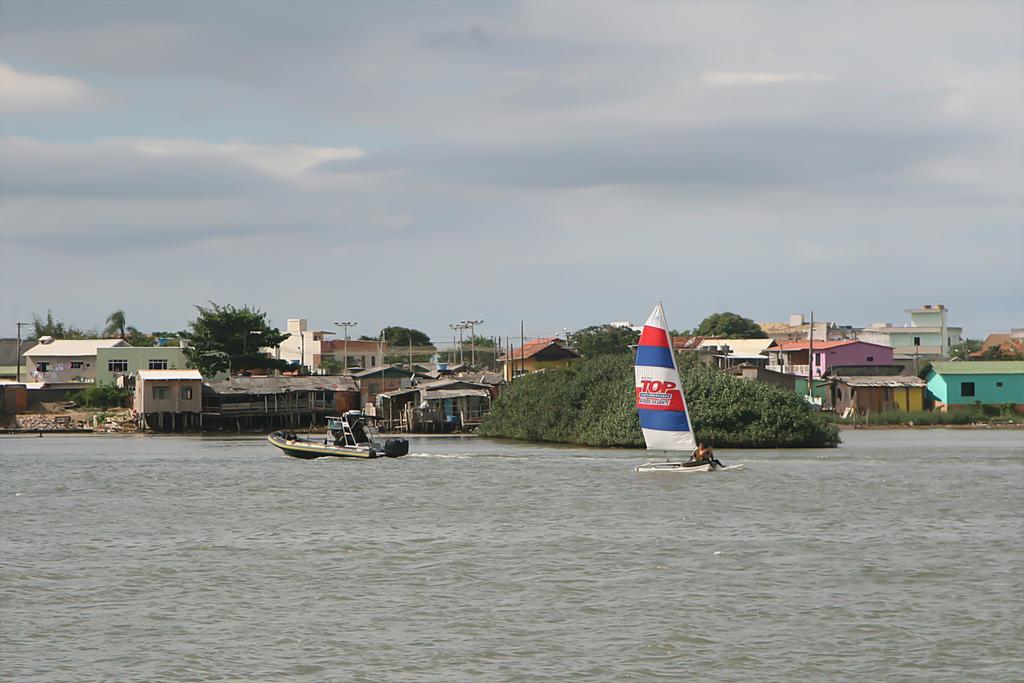Please provide a concise description of this image. In this image I can see two boats on the water, background I can see few trees in green color, few buildings in white, brown, green and yellow color and I can also see few light poles and the sky is in white and blue color. 